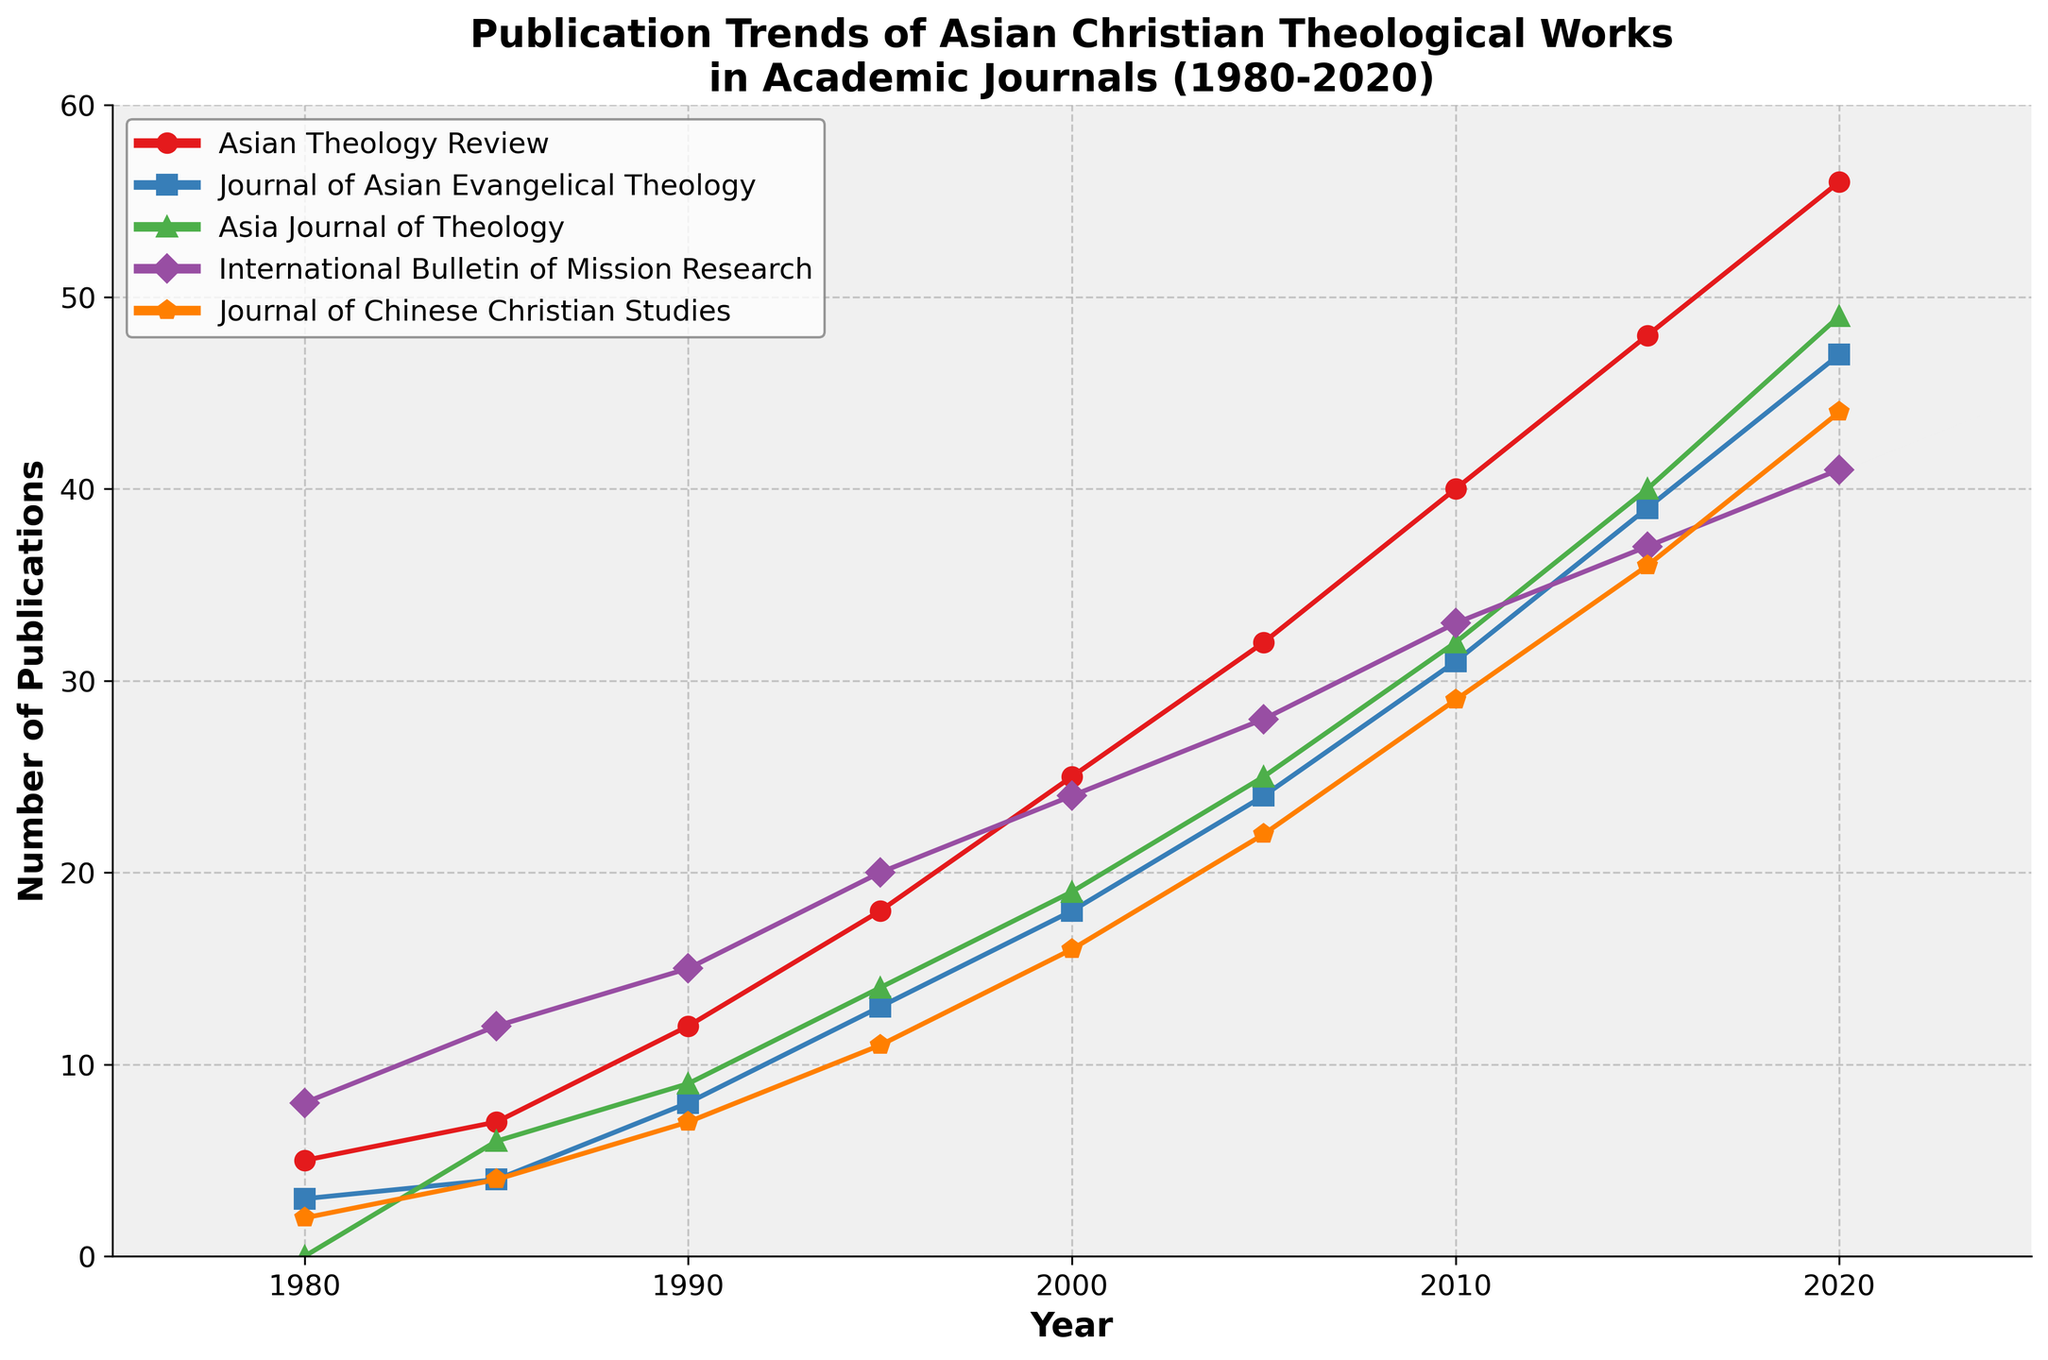What's the overall trend of the publication of theological works in the "Asian Theology Review" from 1980 to 2020? From the figure, we can observe that the number of publications in the "Asian Theology Review" consistently increases from 1980 to 2020. This is seen by the upward trajectory of the red line with circular markers. In 1980, there were 5 publications, and this number grows steadily to 56 publications by 2020.
Answer: Increasing trend Between 2015 and 2020, which journal experienced the greatest increase in the number of publications? To answer this, we need to examine the differences in publication numbers from 2015 to 2020 for each journal. "Asian Theology Review" increased from 48 to 56 (8 publications), "Journal of Asian Evangelical Theology" increased from 39 to 47 (8 publications), "Asia Journal of Theology" increased from 40 to 49 (9 publications), "International Bulletin of Mission Research" increased from 37 to 41 (4 publications), and "Journal of Chinese Christian Studies" increased from 36 to 44 (8 publications). The "Asia Journal of Theology" shows the greatest increase with 9 publications.
Answer: Asia Journal of Theology By how much did the total number of publications across all journals increase from 1980 to 2020? First, find the total number of publications in 1980 and 2020 by summing up the numbers for each journal. In 1980: 5 + 3 + 0 + 8 + 2 = 18. In 2020: 56 + 47 + 49 + 41 + 44 = 237. The increase is 237 - 18 = 219.
Answer: 219 In which year did the "Journal of Chinese Christian Studies" first surpass 10 publications? To find when "Journal of Chinese Christian Studies" surpassed 10 publications, we examine its values across the years. It had 11 publications in 1995, which is the first time it exceeded 10.
Answer: 1995 Which journal had the highest number of publications in 1990, and what was that number? By examining the figure for the year 1990, the journal with the highest publication count is the "International Bulletin of Mission Research" with 15 publications.
Answer: International Bulletin of Mission Research, 15 How many times has the "Journal of Asian Evangelical Theology" produced more publications than the "Asia Journal of Theology"? We need to compare the publications of these two journals across all years. The "Journal of Asian Evangelical Theology" had more publications than the "Asia Journal of Theology" in the years 1980, 1985, and 1990.
Answer: 3 times What color is used to represent the "International Bulletin of Mission Research"? The figure uses colors to represent different journals. The "International Bulletin of Mission Research" is represented by the purple line with distinct markers.
Answer: Purple Calculate the average number of publications for the "Asian Theology Review" between 1980 and 2020. To calculate the average, sum the publications for the "Asian Theology Review" from 1980 to 2020: 5 + 7 + 12 + 18 + 25 + 32 + 40 + 48 + 56 = 243. There are 9 data points, so 243 / 9 = 27.
Answer: 27 In 2010, did any journal have fewer than 20 publications? By examining the figure for the year 2010, all journals have counts: "Asian Theology Review" 40, "Journal of Asian Evangelical Theology" 31, "Asia Journal of Theology" 32, "International Bulletin of Mission Research" 33, and "Journal of Chinese Christian Studies" 29. None have fewer than 20 publications.
Answer: No How many journals had 25 or more publications in 2005? Looking at the figure for the year 2005, the number of publications per journal: "Asian Theology Review" 32, "Journal of Asian Evangelical Theology" 24, "Asia Journal of Theology" 25, "International Bulletin of Mission Research" 28, "Journal of Chinese Christian Studies" 22. Journals with 25 or more publications are the "Asian Theology Review", "Asia Journal of Theology", and "International Bulletin of Mission Research".
Answer: 3 